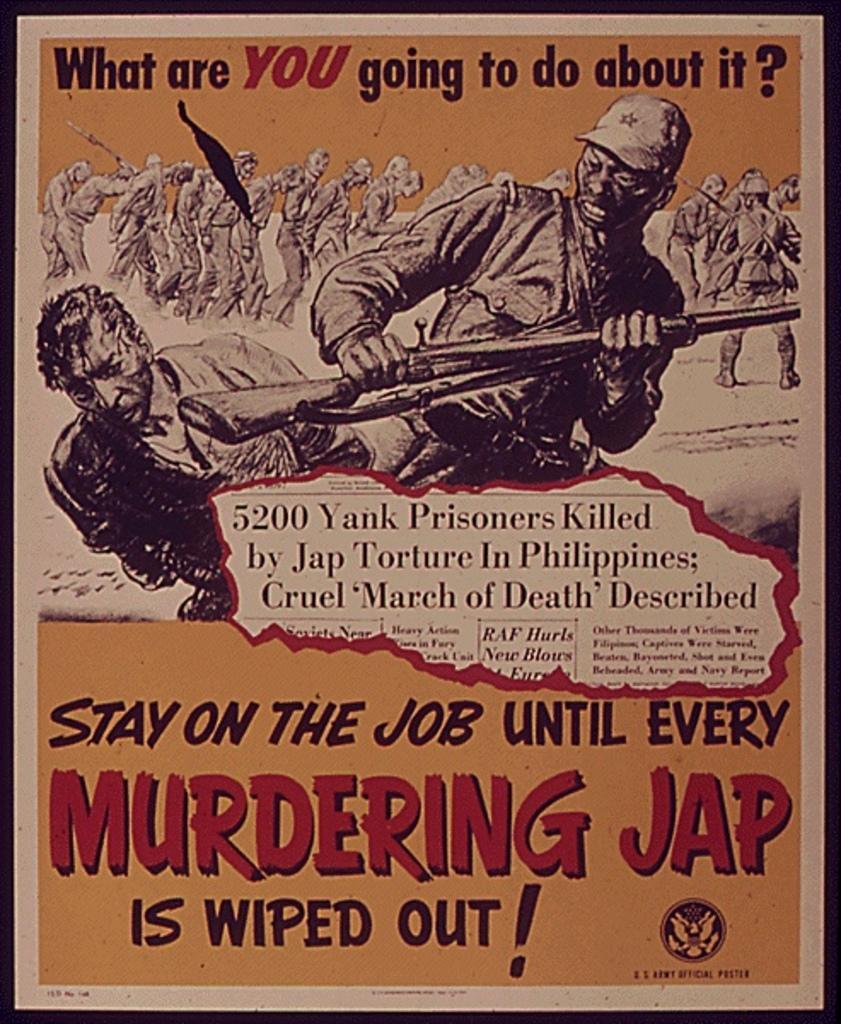Describe this image in one or two sentences. In this image we can see a poster on which some text was written and some sketch are drawn. 